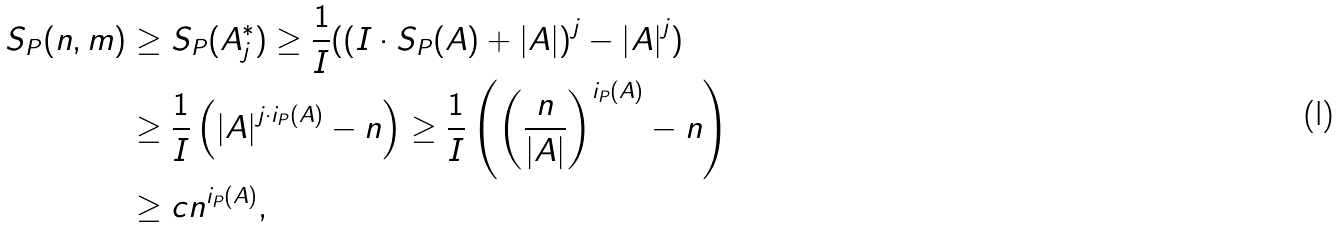<formula> <loc_0><loc_0><loc_500><loc_500>S _ { P } ( n , m ) & \geq S _ { P } ( A _ { j } ^ { \ast } ) \geq \frac { 1 } { I } ( \left ( I \cdot S _ { P } ( A ) + \left | A \right | \right ) ^ { j } - \left | A \right | ^ { j } ) \\ & \geq \frac { 1 } { I } \left ( \left | A \right | ^ { j \cdot i _ { P } ( A ) } - n \right ) \geq \frac { 1 } { I } \left ( \left ( \frac { n } { \left | A \right | } \right ) ^ { i _ { P } ( A ) } - n \right ) \\ & \geq c n ^ { i _ { P } ( A ) } ,</formula> 